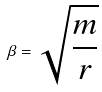Convert formula to latex. <formula><loc_0><loc_0><loc_500><loc_500>\beta = \sqrt { \frac { m } { r } }</formula> 